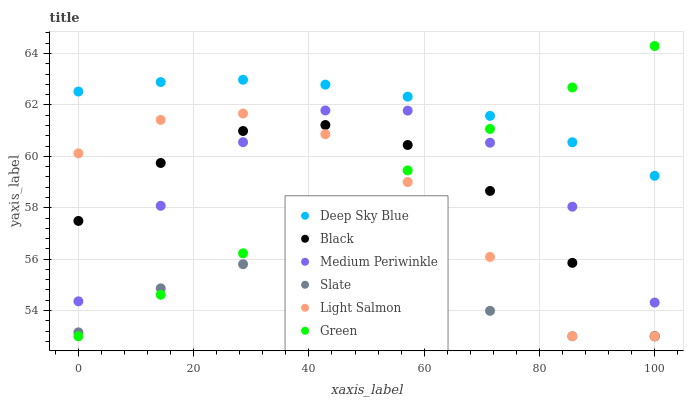Does Slate have the minimum area under the curve?
Answer yes or no. Yes. Does Deep Sky Blue have the maximum area under the curve?
Answer yes or no. Yes. Does Medium Periwinkle have the minimum area under the curve?
Answer yes or no. No. Does Medium Periwinkle have the maximum area under the curve?
Answer yes or no. No. Is Green the smoothest?
Answer yes or no. Yes. Is Light Salmon the roughest?
Answer yes or no. Yes. Is Slate the smoothest?
Answer yes or no. No. Is Slate the roughest?
Answer yes or no. No. Does Light Salmon have the lowest value?
Answer yes or no. Yes. Does Medium Periwinkle have the lowest value?
Answer yes or no. No. Does Green have the highest value?
Answer yes or no. Yes. Does Medium Periwinkle have the highest value?
Answer yes or no. No. Is Light Salmon less than Deep Sky Blue?
Answer yes or no. Yes. Is Deep Sky Blue greater than Light Salmon?
Answer yes or no. Yes. Does Black intersect Medium Periwinkle?
Answer yes or no. Yes. Is Black less than Medium Periwinkle?
Answer yes or no. No. Is Black greater than Medium Periwinkle?
Answer yes or no. No. Does Light Salmon intersect Deep Sky Blue?
Answer yes or no. No. 